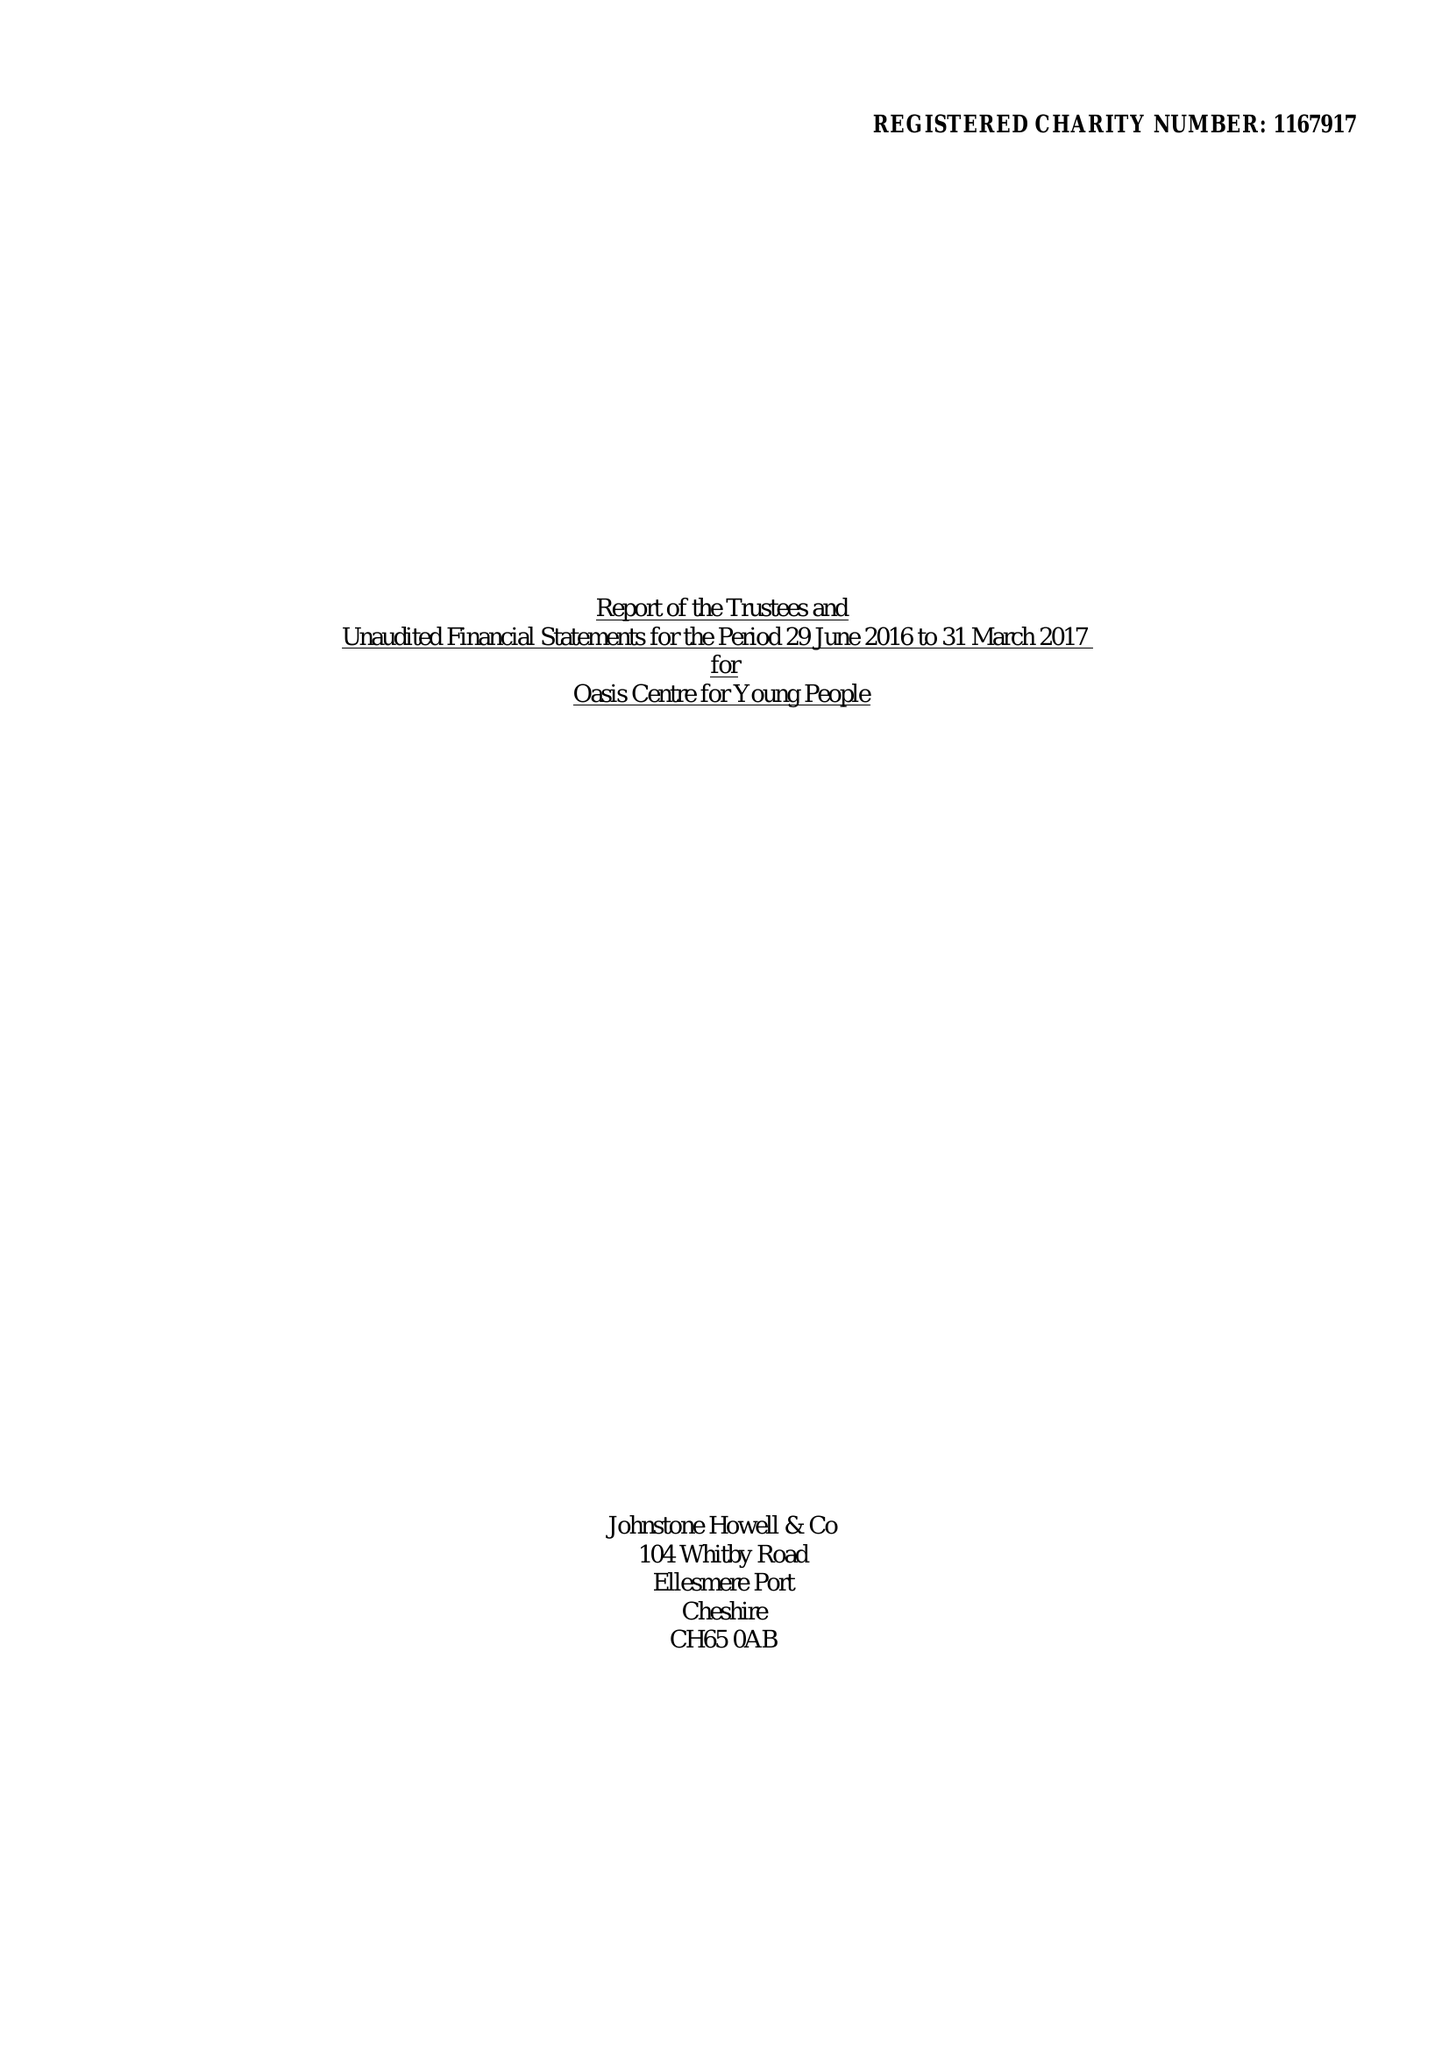What is the value for the spending_annually_in_british_pounds?
Answer the question using a single word or phrase. 18477.00 